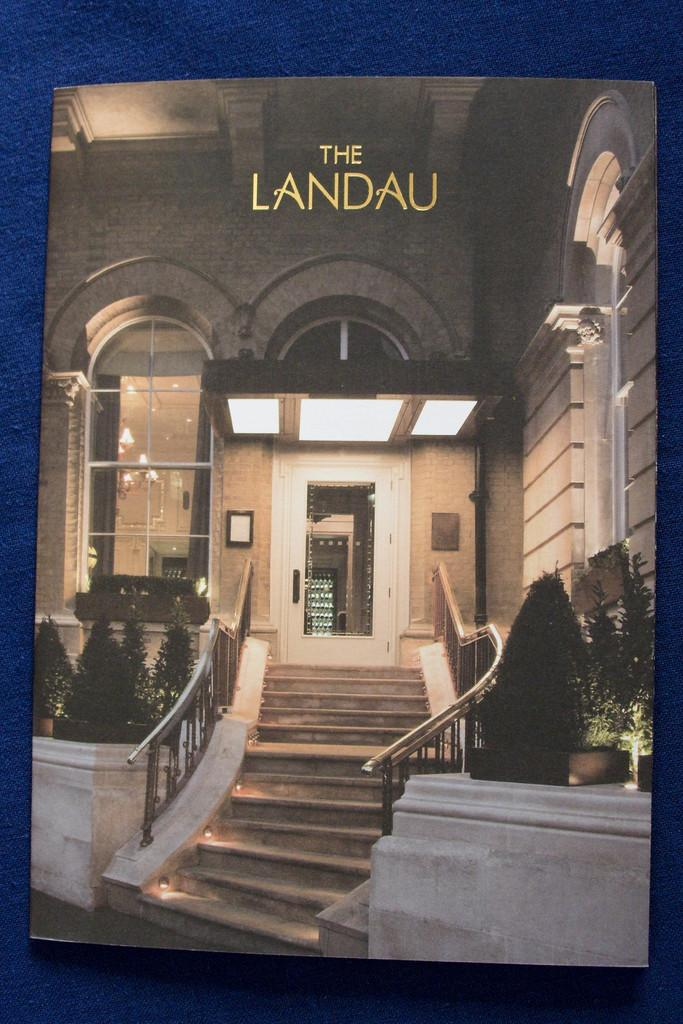<image>
Create a compact narrative representing the image presented. The exterior of The Landau is lit up at night. 